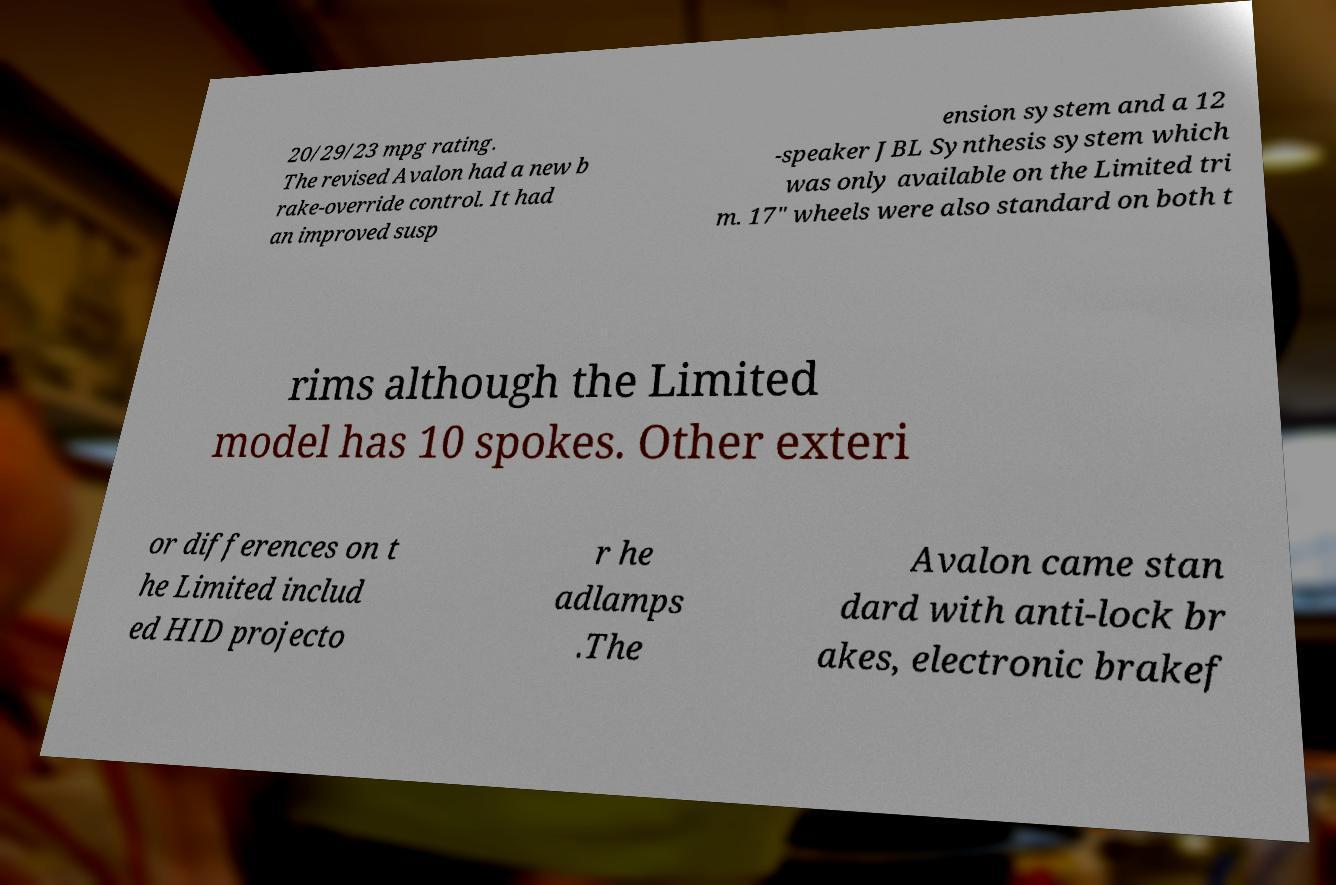Can you read and provide the text displayed in the image?This photo seems to have some interesting text. Can you extract and type it out for me? 20/29/23 mpg rating. The revised Avalon had a new b rake-override control. It had an improved susp ension system and a 12 -speaker JBL Synthesis system which was only available on the Limited tri m. 17" wheels were also standard on both t rims although the Limited model has 10 spokes. Other exteri or differences on t he Limited includ ed HID projecto r he adlamps .The Avalon came stan dard with anti-lock br akes, electronic brakef 